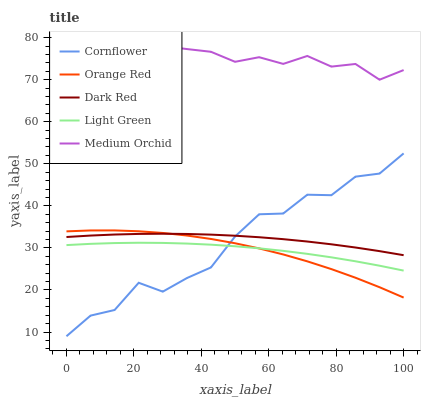Does Orange Red have the minimum area under the curve?
Answer yes or no. Yes. Does Medium Orchid have the maximum area under the curve?
Answer yes or no. Yes. Does Medium Orchid have the minimum area under the curve?
Answer yes or no. No. Does Orange Red have the maximum area under the curve?
Answer yes or no. No. Is Dark Red the smoothest?
Answer yes or no. Yes. Is Cornflower the roughest?
Answer yes or no. Yes. Is Medium Orchid the smoothest?
Answer yes or no. No. Is Medium Orchid the roughest?
Answer yes or no. No. Does Cornflower have the lowest value?
Answer yes or no. Yes. Does Orange Red have the lowest value?
Answer yes or no. No. Does Medium Orchid have the highest value?
Answer yes or no. Yes. Does Orange Red have the highest value?
Answer yes or no. No. Is Orange Red less than Medium Orchid?
Answer yes or no. Yes. Is Medium Orchid greater than Dark Red?
Answer yes or no. Yes. Does Light Green intersect Orange Red?
Answer yes or no. Yes. Is Light Green less than Orange Red?
Answer yes or no. No. Is Light Green greater than Orange Red?
Answer yes or no. No. Does Orange Red intersect Medium Orchid?
Answer yes or no. No. 